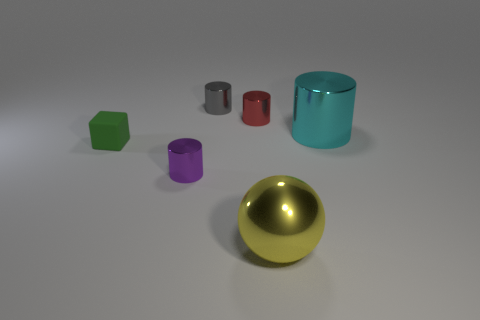Subtract all cyan shiny cylinders. How many cylinders are left? 3 Add 3 big yellow metal things. How many objects exist? 9 Subtract all red cylinders. How many cylinders are left? 3 Subtract all cylinders. How many objects are left? 2 Subtract all yellow cylinders. Subtract all cyan cubes. How many cylinders are left? 4 Add 4 tiny green cylinders. How many tiny green cylinders exist? 4 Subtract 0 red spheres. How many objects are left? 6 Subtract all red cylinders. Subtract all large objects. How many objects are left? 3 Add 6 green objects. How many green objects are left? 7 